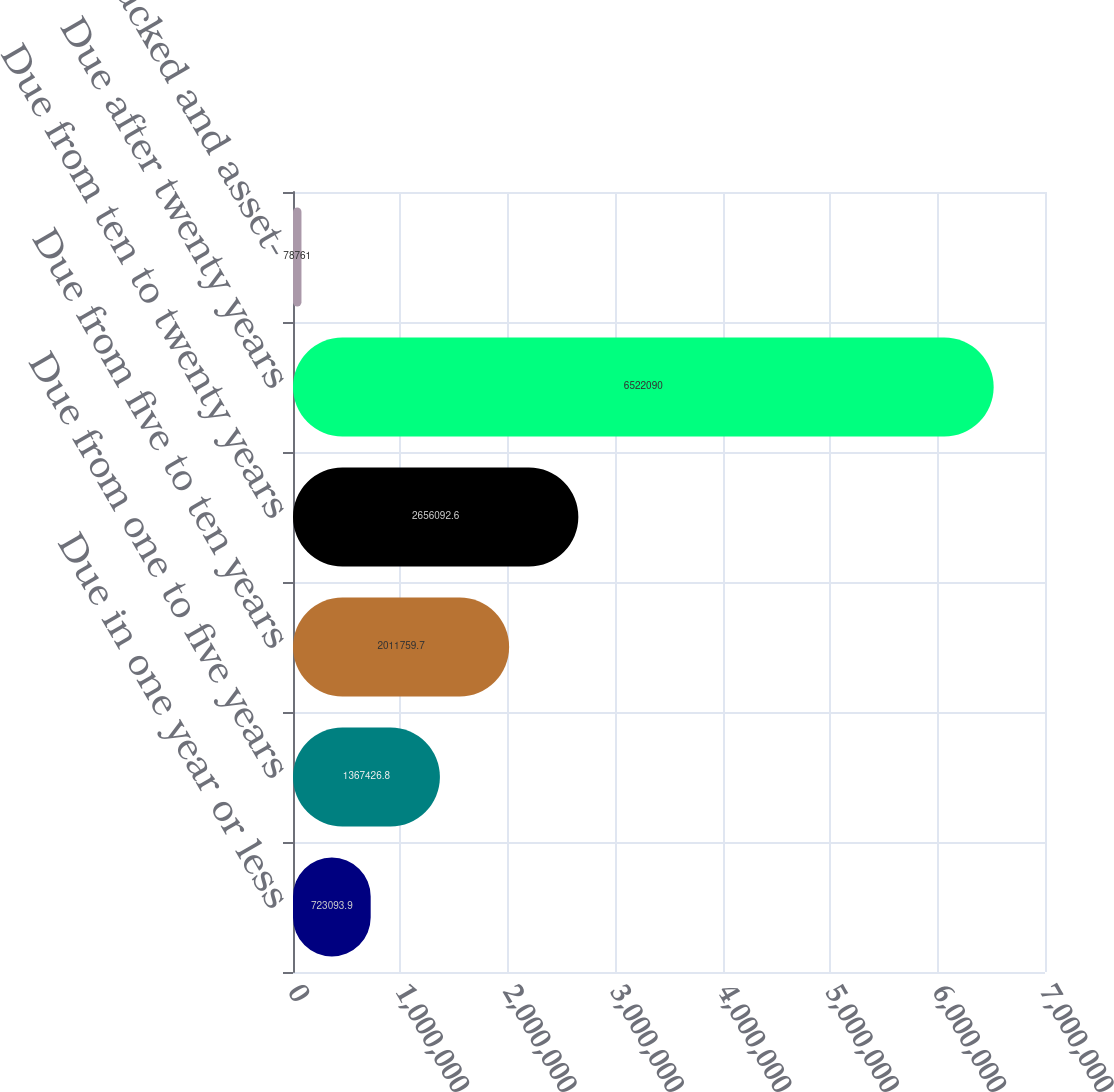Convert chart to OTSL. <chart><loc_0><loc_0><loc_500><loc_500><bar_chart><fcel>Due in one year or less<fcel>Due from one to five years<fcel>Due from five to ten years<fcel>Due from ten to twenty years<fcel>Due after twenty years<fcel>Mortgage-backed and asset-<nl><fcel>723094<fcel>1.36743e+06<fcel>2.01176e+06<fcel>2.65609e+06<fcel>6.52209e+06<fcel>78761<nl></chart> 